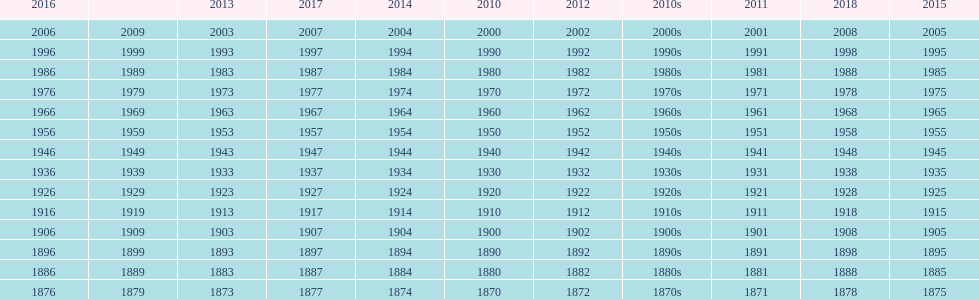True/false: all years go in consecutive order? True. 